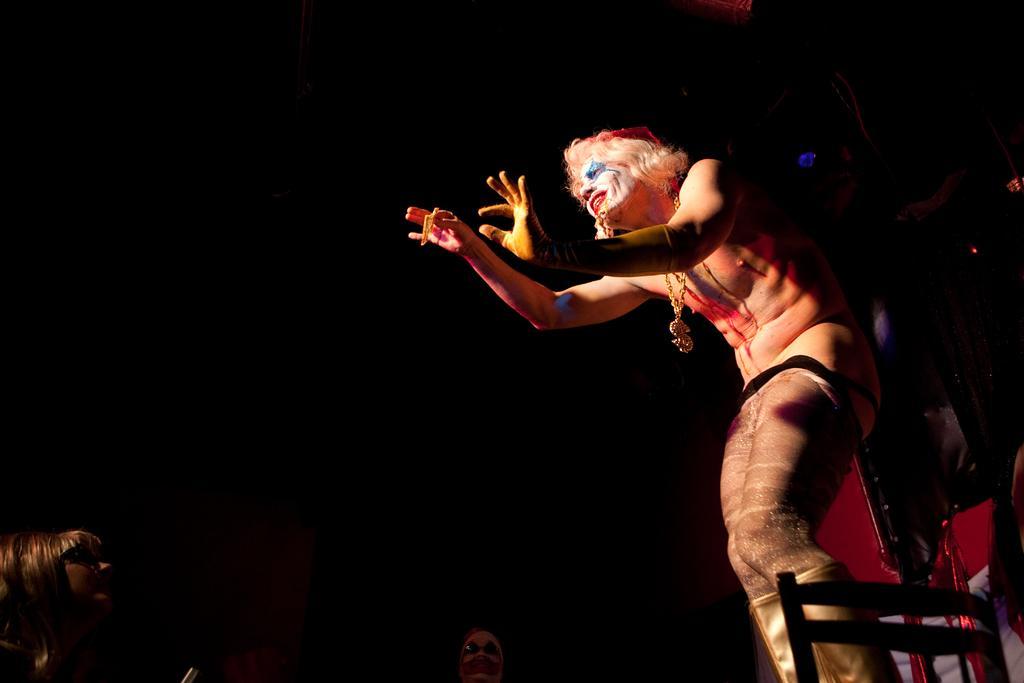In one or two sentences, can you explain what this image depicts? In this image I can see three people. To the side I can see some objects and there is a black background. 